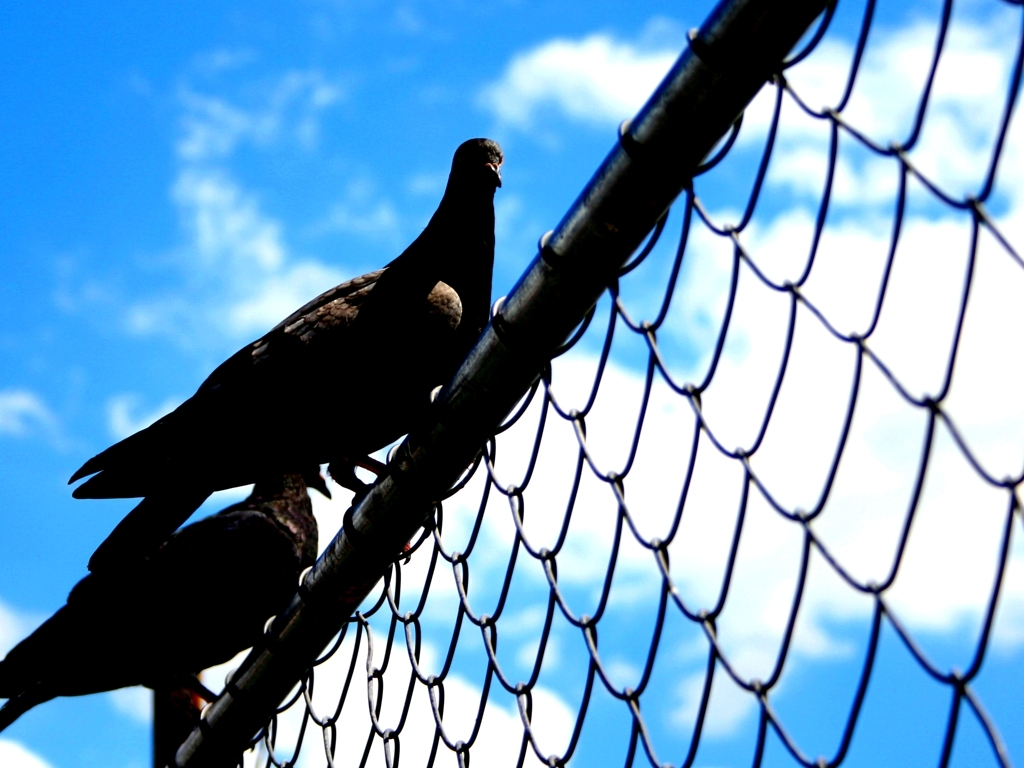Is there any indication of the environment beyond what's visible in the photo? While the image focuses on the pigeon and the fence, the clear sky gives an indirect indication of the broader environment being open and possibly situated in a spacious area, such as a park or a city square. The absence of buildings or trees in the immediate backdrop may imply an unobstructed aerial space, which is often suitable for birds like pigeons to fly and roost. 